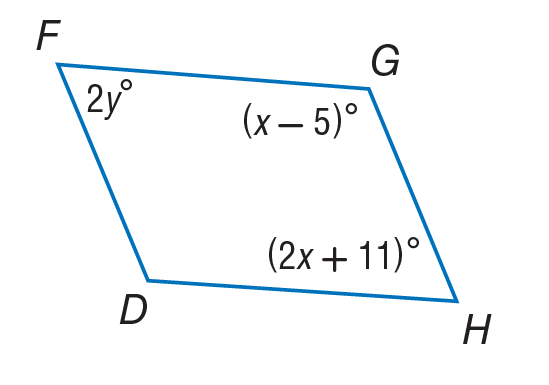Answer the mathemtical geometry problem and directly provide the correct option letter.
Question: Use parallelogram to find y.
Choices: A: 26.5 B: 53 C: 63.5 D: 127 C 